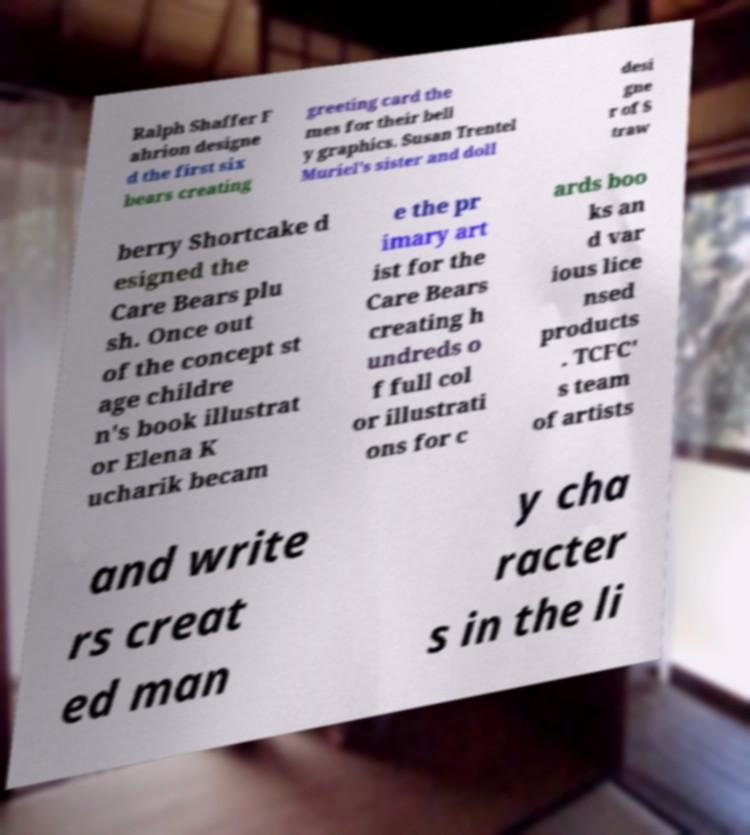I need the written content from this picture converted into text. Can you do that? Ralph Shaffer F ahrion designe d the first six bears creating greeting card the mes for their bell y graphics. Susan Trentel Muriel's sister and doll desi gne r of S traw berry Shortcake d esigned the Care Bears plu sh. Once out of the concept st age childre n's book illustrat or Elena K ucharik becam e the pr imary art ist for the Care Bears creating h undreds o f full col or illustrati ons for c ards boo ks an d var ious lice nsed products . TCFC' s team of artists and write rs creat ed man y cha racter s in the li 